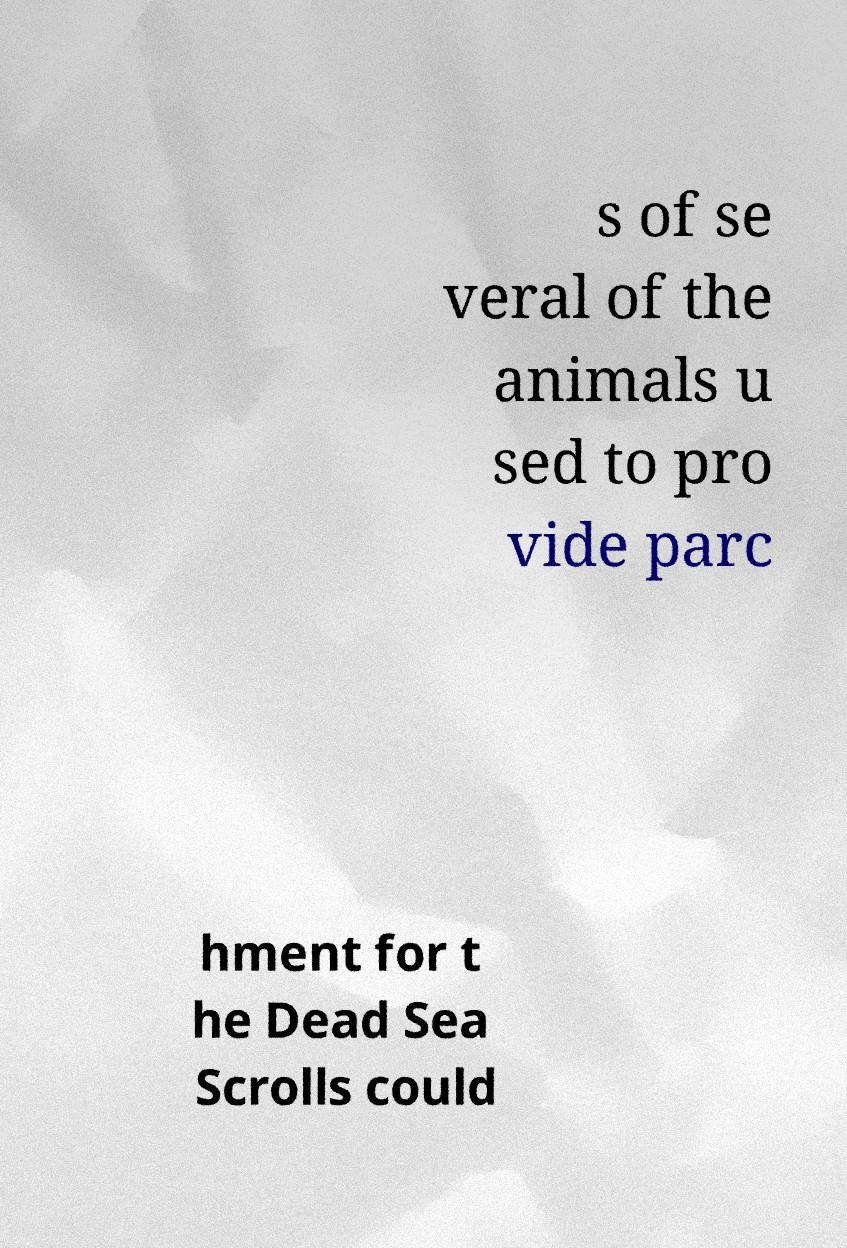For documentation purposes, I need the text within this image transcribed. Could you provide that? s of se veral of the animals u sed to pro vide parc hment for t he Dead Sea Scrolls could 